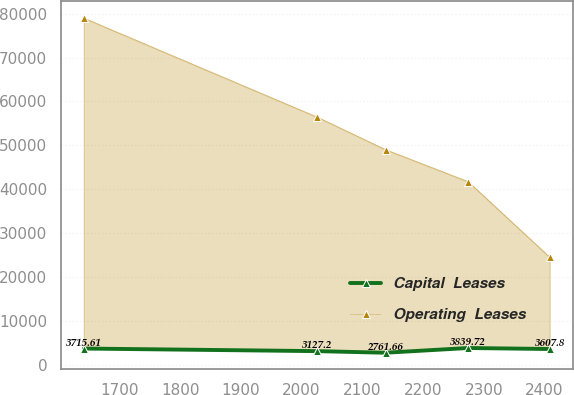<chart> <loc_0><loc_0><loc_500><loc_500><line_chart><ecel><fcel>Capital  Leases<fcel>Operating  Leases<nl><fcel>1641.37<fcel>3715.61<fcel>78991.2<nl><fcel>2025.11<fcel>3127.2<fcel>56478.8<nl><fcel>2138.29<fcel>2761.66<fcel>49032.2<nl><fcel>2274.35<fcel>3839.72<fcel>41748.8<nl><fcel>2408.76<fcel>3607.8<fcel>24525<nl></chart> 